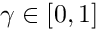<formula> <loc_0><loc_0><loc_500><loc_500>\gamma \in [ 0 , 1 ]</formula> 